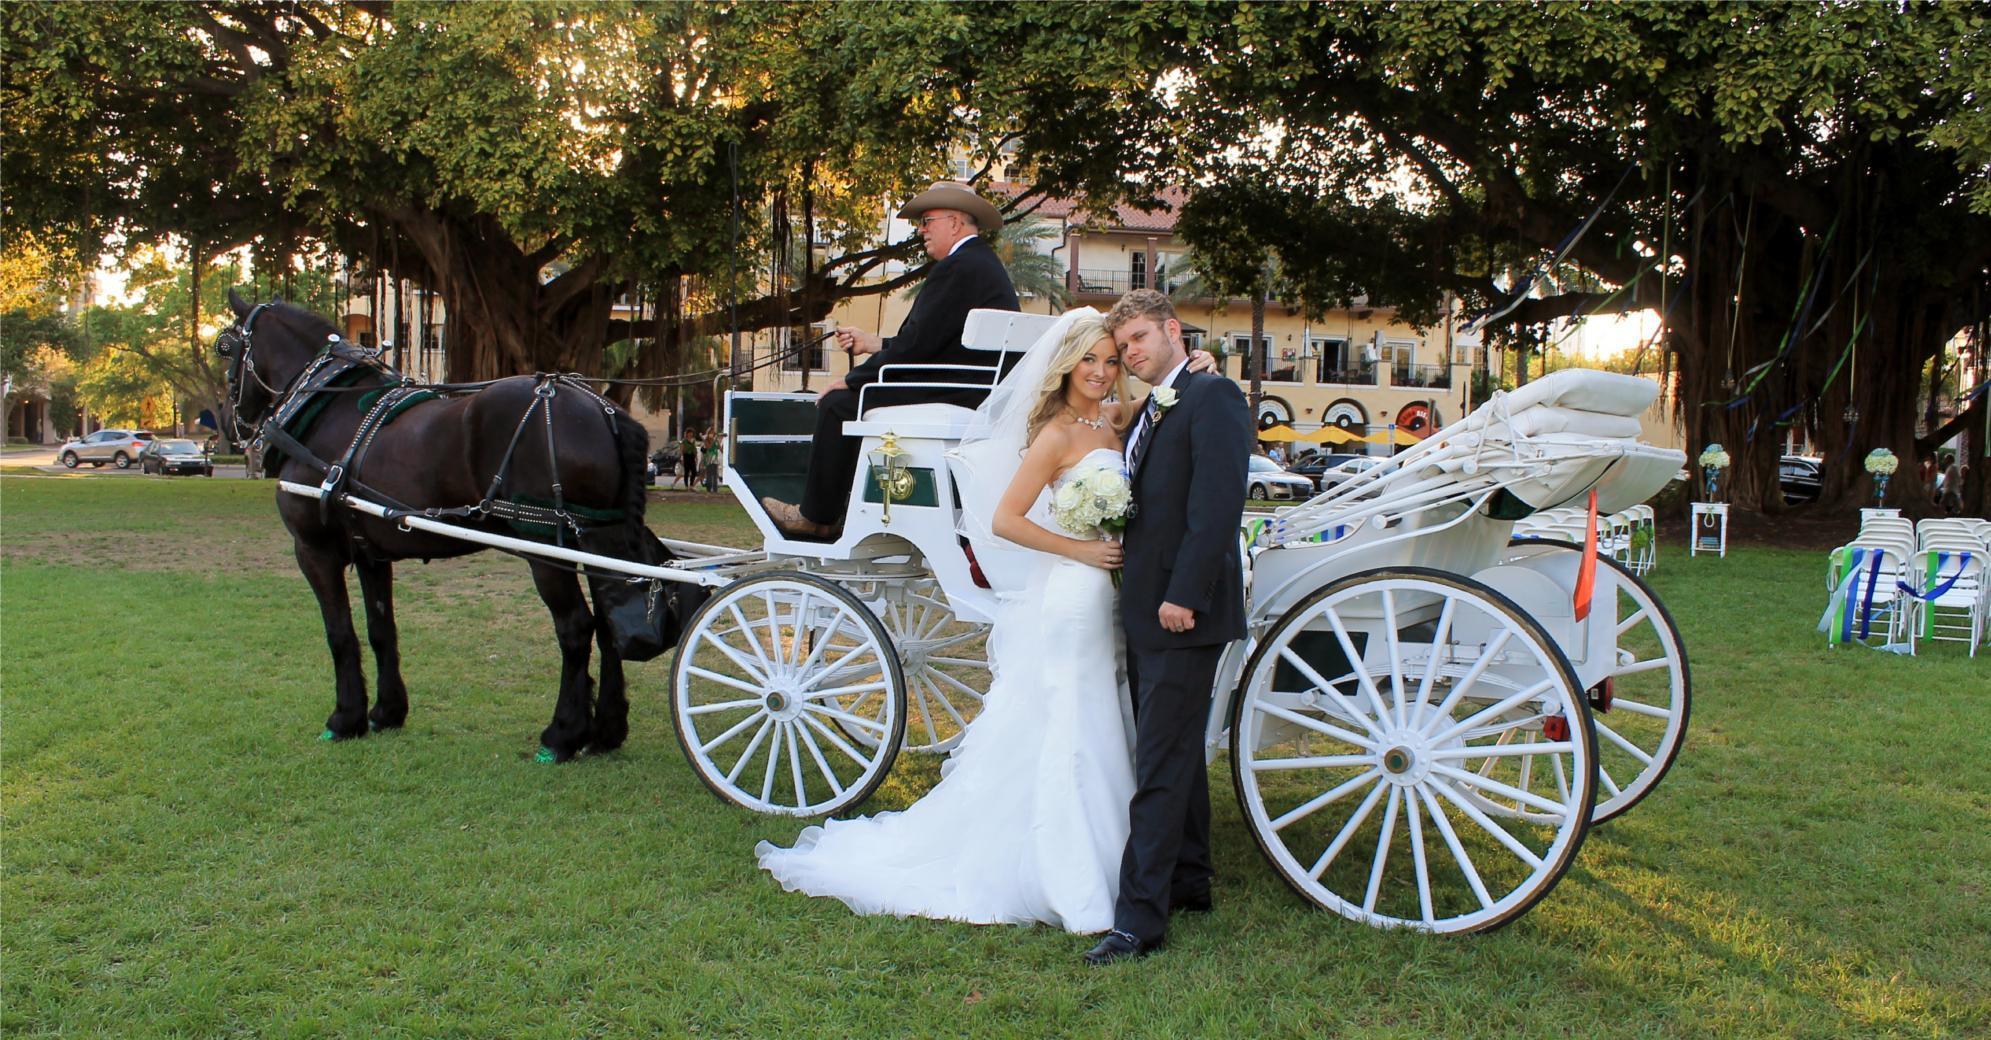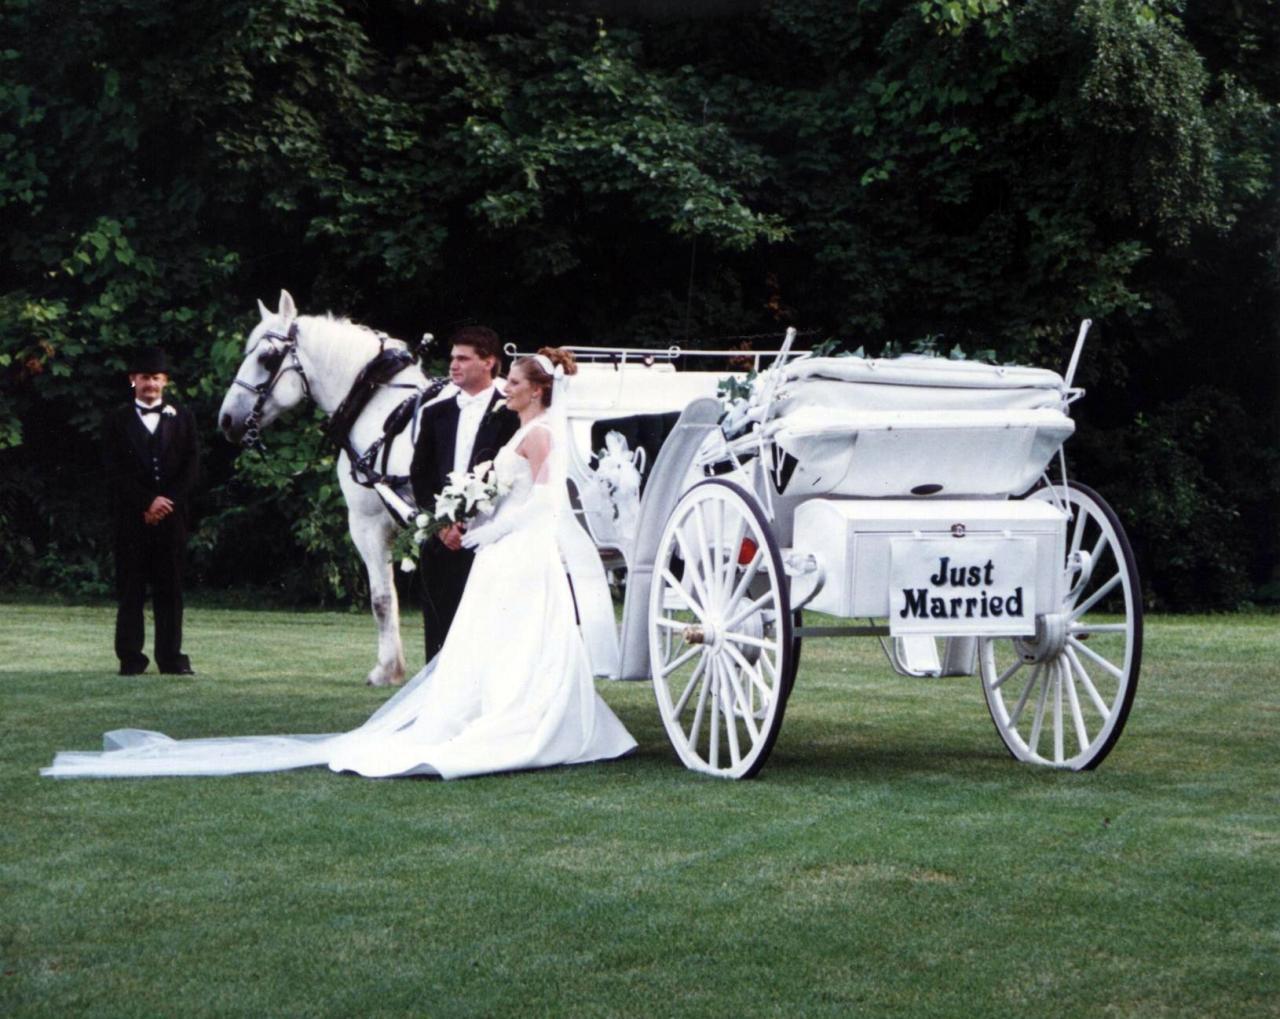The first image is the image on the left, the second image is the image on the right. Evaluate the accuracy of this statement regarding the images: "Nine or more mammals are visible.". Is it true? Answer yes or no. No. The first image is the image on the left, the second image is the image on the right. Considering the images on both sides, is "In both images, a bride is visible next to a horse and carriage." valid? Answer yes or no. Yes. 